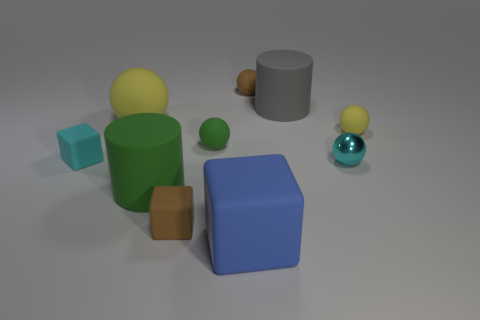Subtract all blue blocks. How many yellow spheres are left? 2 Subtract all green balls. How many balls are left? 4 Subtract 1 blocks. How many blocks are left? 2 Subtract all cyan spheres. How many spheres are left? 4 Subtract all cylinders. How many objects are left? 8 Subtract 1 blue cubes. How many objects are left? 9 Subtract all gray blocks. Subtract all blue cylinders. How many blocks are left? 3 Subtract all brown rubber cubes. Subtract all big blue rubber things. How many objects are left? 8 Add 2 large gray matte cylinders. How many large gray matte cylinders are left? 3 Add 4 big gray matte things. How many big gray matte things exist? 5 